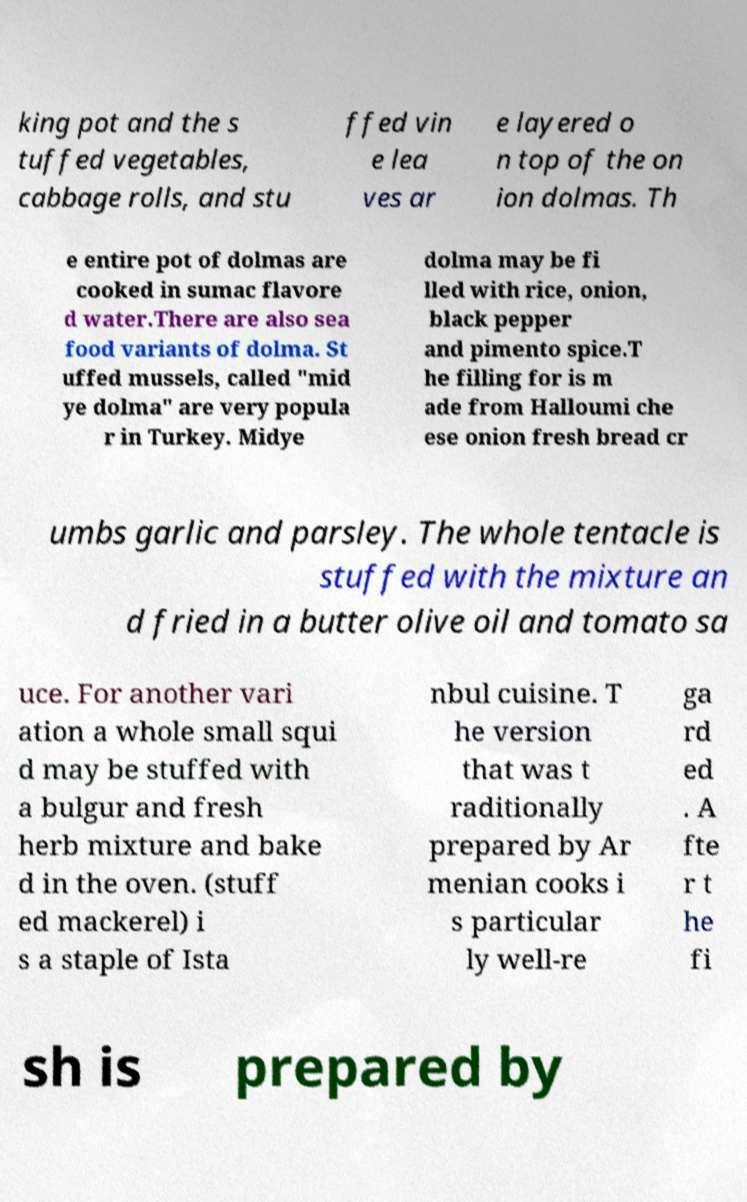Could you extract and type out the text from this image? king pot and the s tuffed vegetables, cabbage rolls, and stu ffed vin e lea ves ar e layered o n top of the on ion dolmas. Th e entire pot of dolmas are cooked in sumac flavore d water.There are also sea food variants of dolma. St uffed mussels, called "mid ye dolma" are very popula r in Turkey. Midye dolma may be fi lled with rice, onion, black pepper and pimento spice.T he filling for is m ade from Halloumi che ese onion fresh bread cr umbs garlic and parsley. The whole tentacle is stuffed with the mixture an d fried in a butter olive oil and tomato sa uce. For another vari ation a whole small squi d may be stuffed with a bulgur and fresh herb mixture and bake d in the oven. (stuff ed mackerel) i s a staple of Ista nbul cuisine. T he version that was t raditionally prepared by Ar menian cooks i s particular ly well-re ga rd ed . A fte r t he fi sh is prepared by 